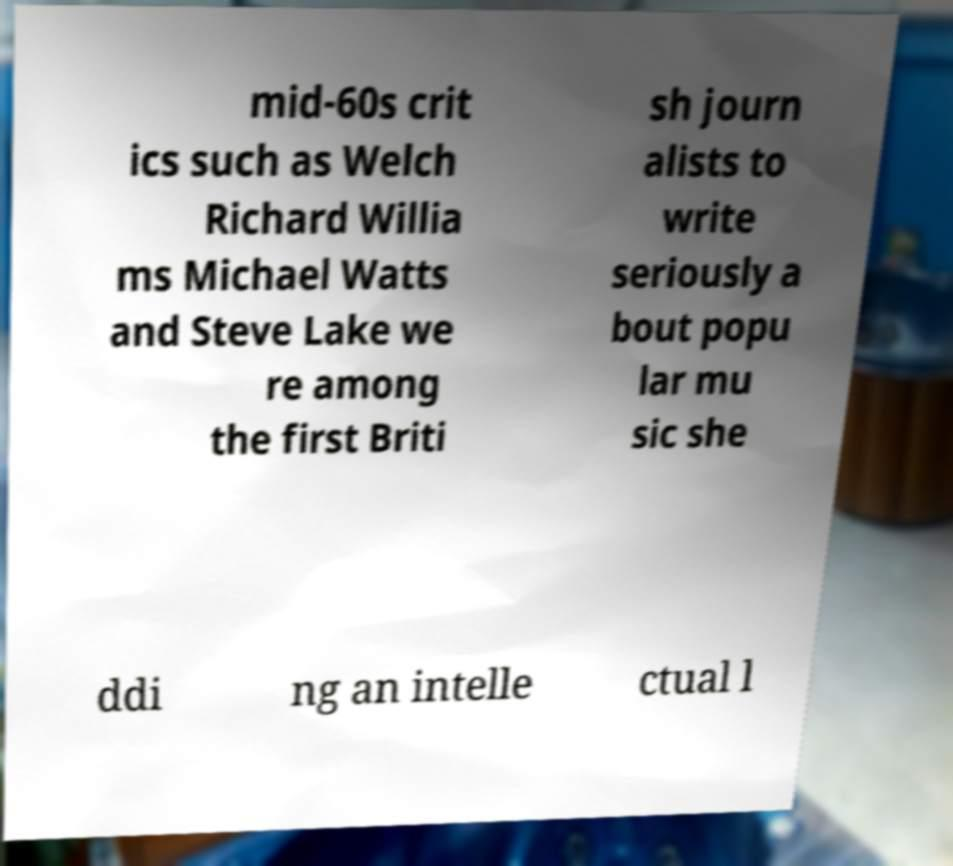Please identify and transcribe the text found in this image. mid-60s crit ics such as Welch Richard Willia ms Michael Watts and Steve Lake we re among the first Briti sh journ alists to write seriously a bout popu lar mu sic she ddi ng an intelle ctual l 